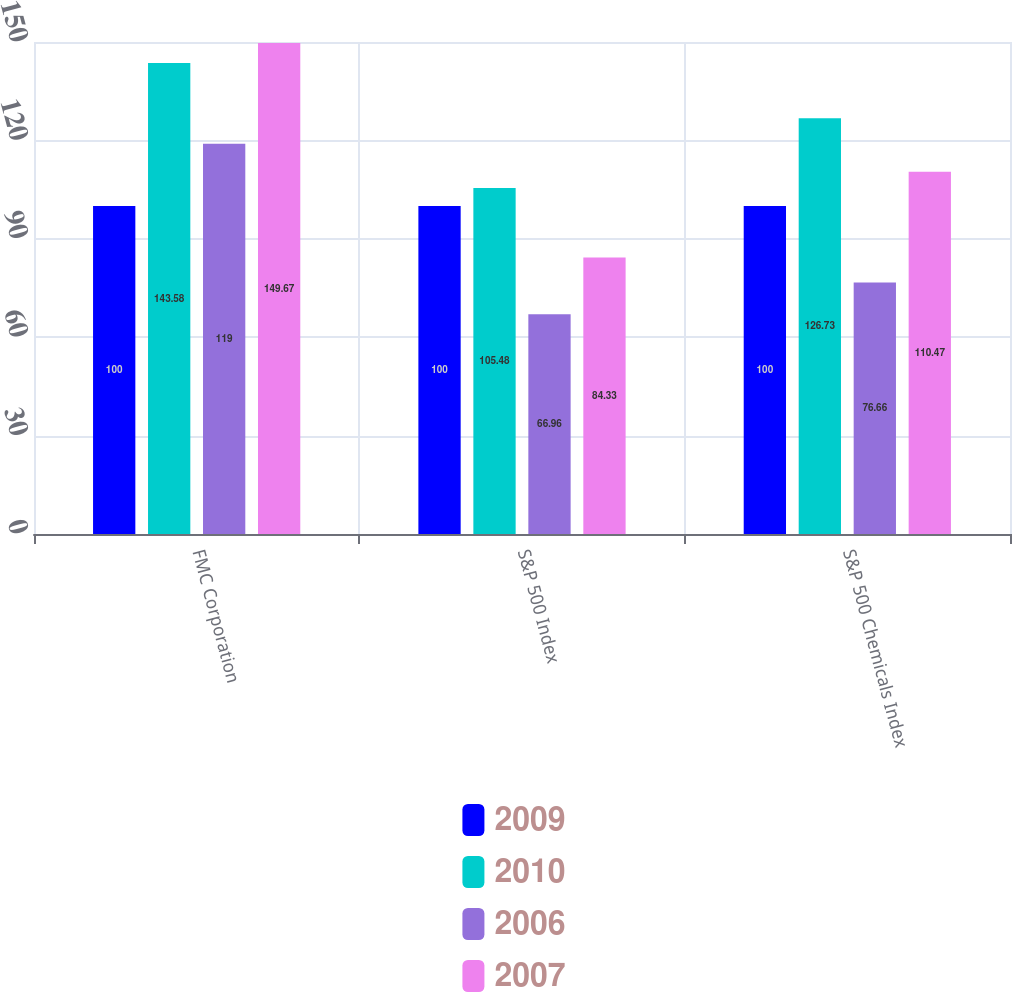Convert chart to OTSL. <chart><loc_0><loc_0><loc_500><loc_500><stacked_bar_chart><ecel><fcel>FMC Corporation<fcel>S&P 500 Index<fcel>S&P 500 Chemicals Index<nl><fcel>2009<fcel>100<fcel>100<fcel>100<nl><fcel>2010<fcel>143.58<fcel>105.48<fcel>126.73<nl><fcel>2006<fcel>119<fcel>66.96<fcel>76.66<nl><fcel>2007<fcel>149.67<fcel>84.33<fcel>110.47<nl></chart> 